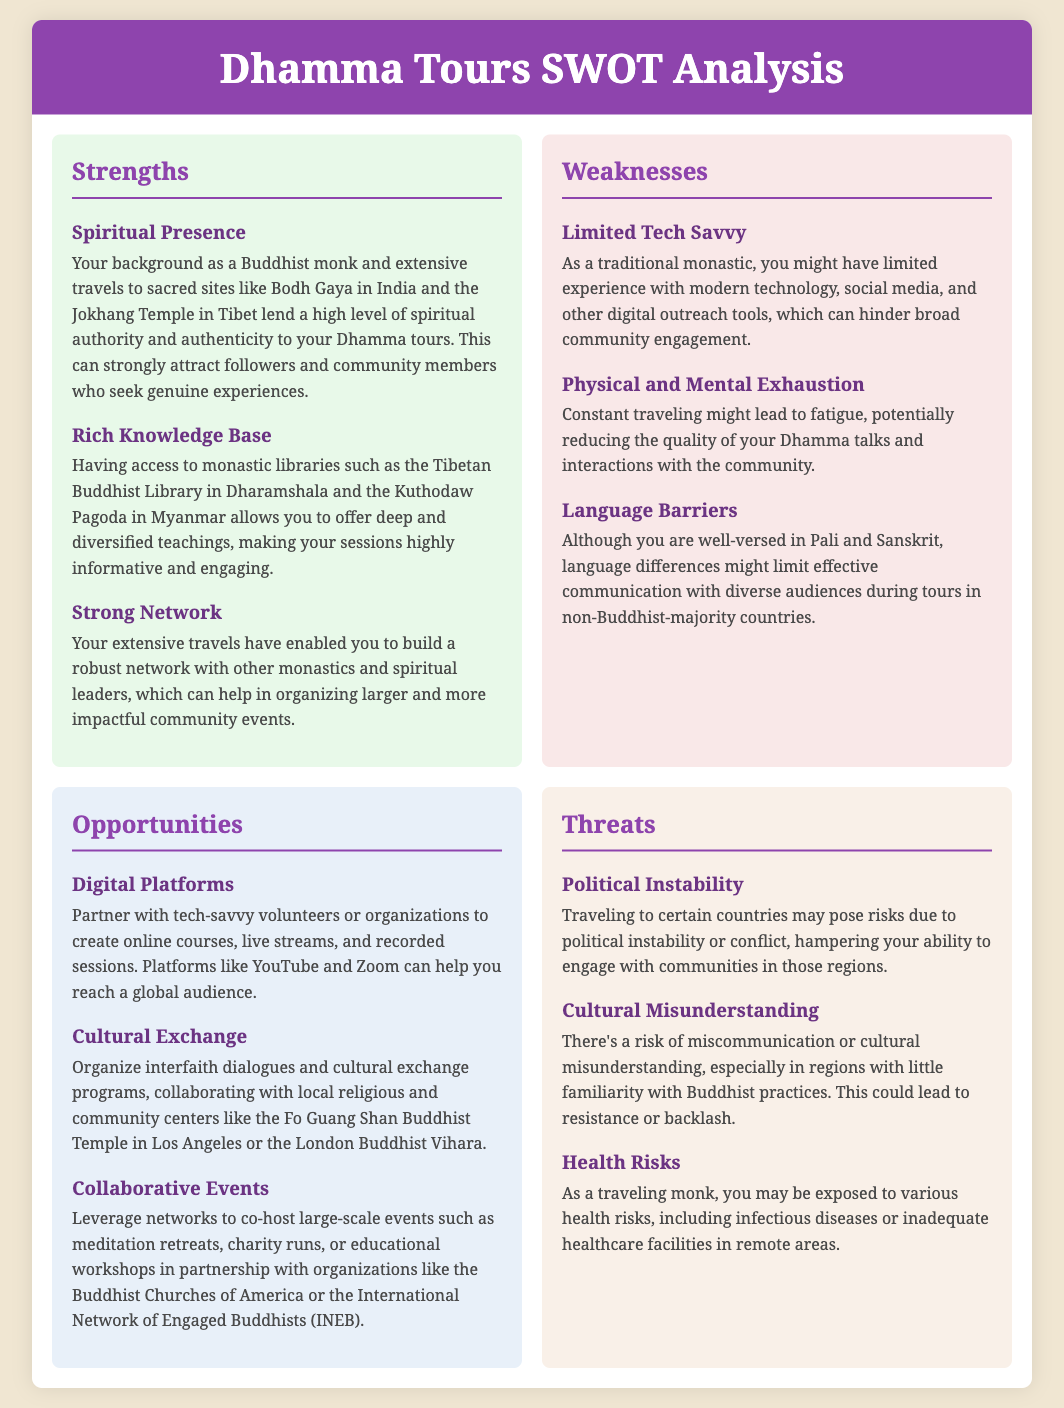What is one strength of your Dhamma tours? A strength mentioned is your background as a Buddhist monk and extensive travels to sacred sites, which lend spiritual authority.
Answer: Spiritual Presence What is the primary weakness related to technology? The document states that as a traditional monastic, you might have limited experience with modern technology and digital outreach tools.
Answer: Limited Tech Savvy Name an opportunity that involves digital platforms. A suggested opportunity is to partner with tech-savvy volunteers to create online courses and live streams.
Answer: Digital Platforms What threat is associated with health risks? A health risk mentioned is exposure to various infectious diseases or inadequate healthcare facilities.
Answer: Health Risks How many strengths are listed in the document? The document lists three strengths in total under the strengths section.
Answer: 3 What is one potential cultural issue mentioned? The document discusses the risk of miscommunication or cultural misunderstanding in areas unfamiliar with Buddhist practices.
Answer: Cultural Misunderstanding Which section covers the risk of political instability? The risk of political instability is discussed in the threats section of the document.
Answer: Threats What kind of events can you leverage networks for? You can leverage networks to co-host large-scale events like meditation retreats and educational workshops.
Answer: Collaborative Events 